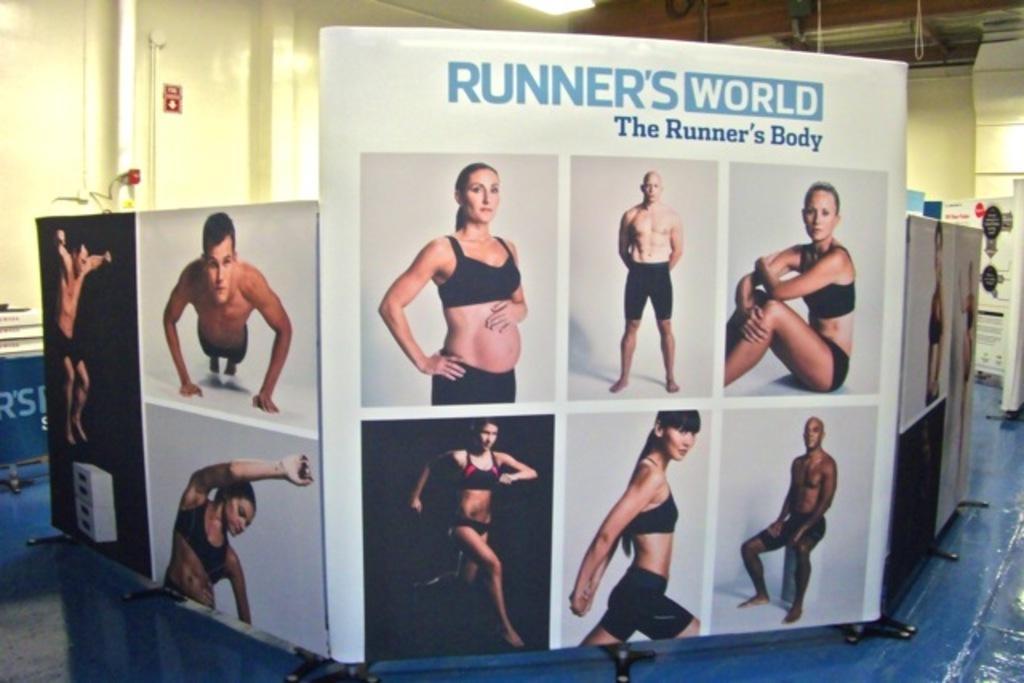What type of banners are present in the image? There are white banners in the image. What is depicted on the banners? The banners have images of people on them. What is located at the back of the image? There is a wall at the back of the image. Where is the light source in the image? There is a light on the top of the image. Is there a bike parked next to the wall in the image? There is no bike present in the image. What story is being told by the images on the banners? The images on the banners do not tell a story; they simply depict people. 